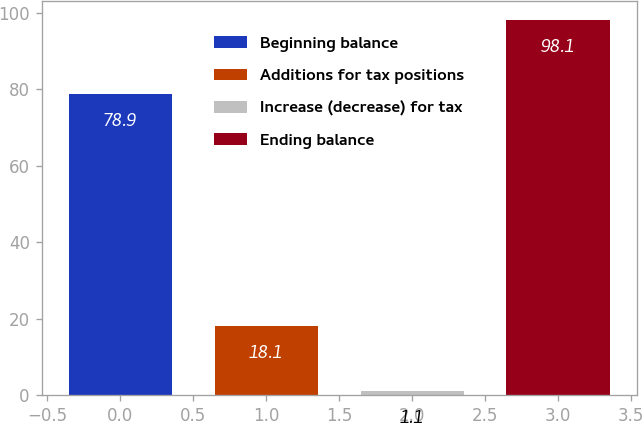<chart> <loc_0><loc_0><loc_500><loc_500><bar_chart><fcel>Beginning balance<fcel>Additions for tax positions<fcel>Increase (decrease) for tax<fcel>Ending balance<nl><fcel>78.9<fcel>18.1<fcel>1.1<fcel>98.1<nl></chart> 